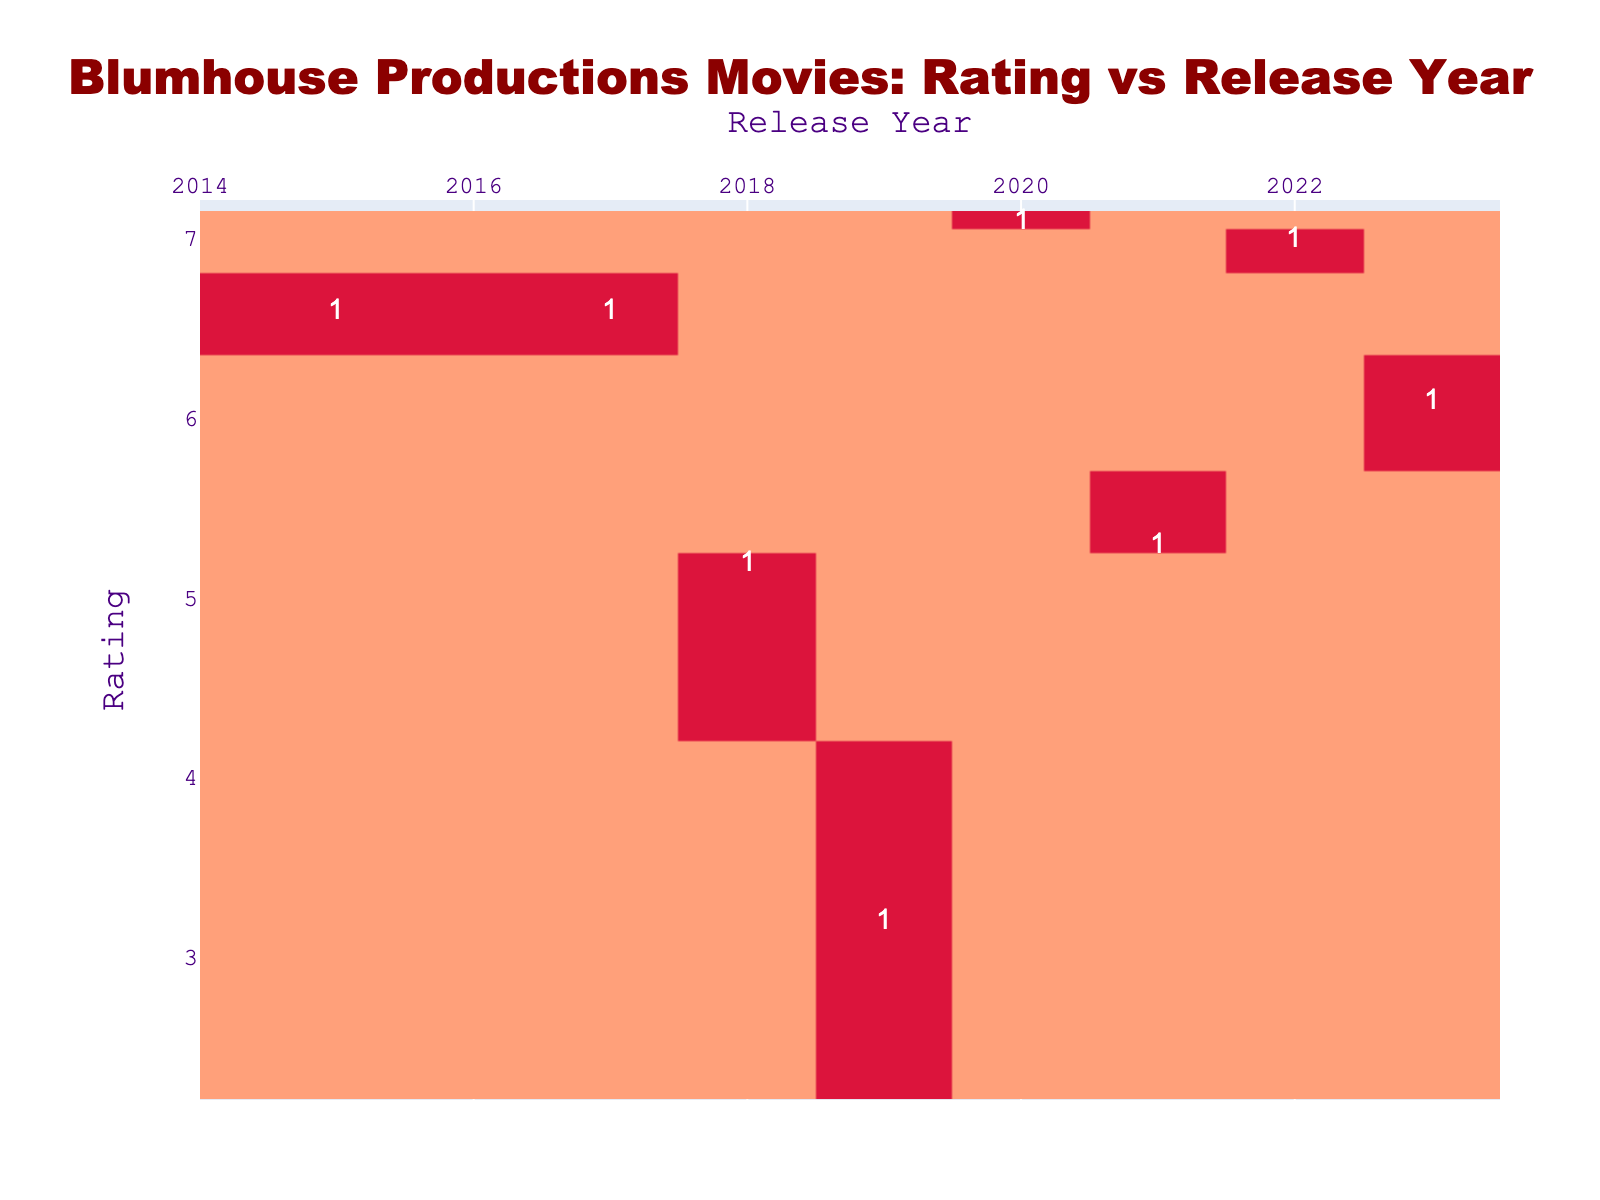What is the highest-rated Blumhouse movie in the year 2020? In the year 2020, the only Blumhouse movie listed in the table is "The Invisible Man," which has a rating of 7.1.
Answer: 7.1 Which streaming service has the most movies listed? The streaming services listed are Netflix, Hulu, Amazon Prime Video, HBO Max, Peacock, and Paramount+. Each appears once, so none has more movies than the others in this dataset.
Answer: No Is there a Blumhouse movie released in 2019 with a rating over 5? The movie "Black Christmas" was released in 2019, and it has a rating of 3.2, which does not satisfy the condition.
Answer: No How many movies released in 2022 and 2023 had a rating above 6? For 2022, "The Black Phone" has a rating of 7.0, and for 2023, "Five Nights at Freddy's" has a rating of 6.1. Only "The Black Phone" has a rating above 6. Thus, there is 1 movie.
Answer: 1 What is the average rating of all the Blumhouse movies listed in the table? The ratings for all movies are 6.6, 6.6, 5.2, 3.2, 7.1, 5.3, 7.0, and 6.1. Adding them gives 41.1, and there are 8 movies, so the average is 41.1/8 = 5.1375.
Answer: 5.14 Which year had the lowest-rated Blumhouse movie? The lowest rating is 3.2, which belongs to "Black Christmas" released in 2019. Thus, 2019 had the lowest-rated movie.
Answer: 2019 How many movies are available on Peacock? The movies listed available on Peacock are "The Invisible Man" and "Five Nights at Freddy's." Therefore, there are 2 movies available on Peacock.
Answer: 2 What two ratings belong to movies available on Amazon Prime Video? The movies available on Amazon Prime Video are "Blumhouse's Truth or Dare" with a rating of 5.2 and "BLUMHOUSE'S THE BOWERY" with a rating of 5.3. The two ratings are 5.2 and 5.3.
Answer: 5.2 and 5.3 